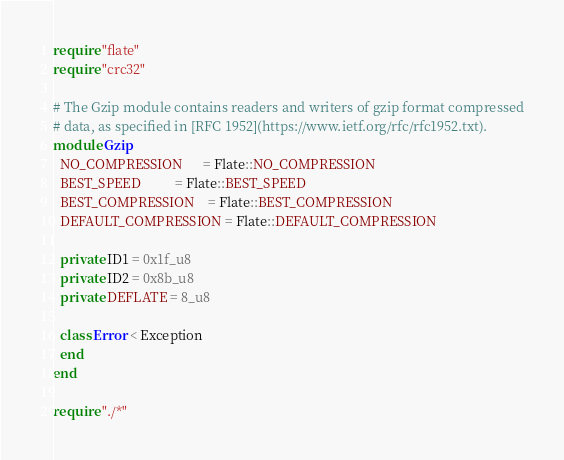Convert code to text. <code><loc_0><loc_0><loc_500><loc_500><_Crystal_>require "flate"
require "crc32"

# The Gzip module contains readers and writers of gzip format compressed
# data, as specified in [RFC 1952](https://www.ietf.org/rfc/rfc1952.txt).
module Gzip
  NO_COMPRESSION      = Flate::NO_COMPRESSION
  BEST_SPEED          = Flate::BEST_SPEED
  BEST_COMPRESSION    = Flate::BEST_COMPRESSION
  DEFAULT_COMPRESSION = Flate::DEFAULT_COMPRESSION

  private ID1 = 0x1f_u8
  private ID2 = 0x8b_u8
  private DEFLATE = 8_u8

  class Error < Exception
  end
end

require "./*"
</code> 